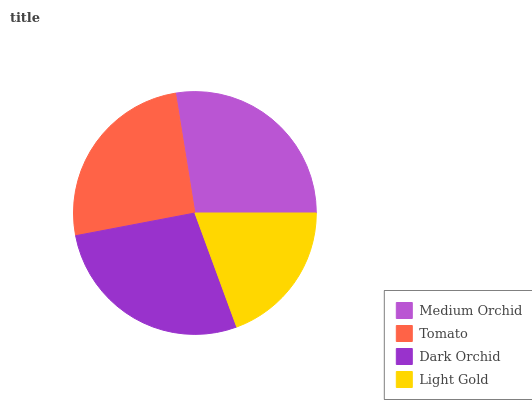Is Light Gold the minimum?
Answer yes or no. Yes. Is Dark Orchid the maximum?
Answer yes or no. Yes. Is Tomato the minimum?
Answer yes or no. No. Is Tomato the maximum?
Answer yes or no. No. Is Medium Orchid greater than Tomato?
Answer yes or no. Yes. Is Tomato less than Medium Orchid?
Answer yes or no. Yes. Is Tomato greater than Medium Orchid?
Answer yes or no. No. Is Medium Orchid less than Tomato?
Answer yes or no. No. Is Medium Orchid the high median?
Answer yes or no. Yes. Is Tomato the low median?
Answer yes or no. Yes. Is Light Gold the high median?
Answer yes or no. No. Is Medium Orchid the low median?
Answer yes or no. No. 